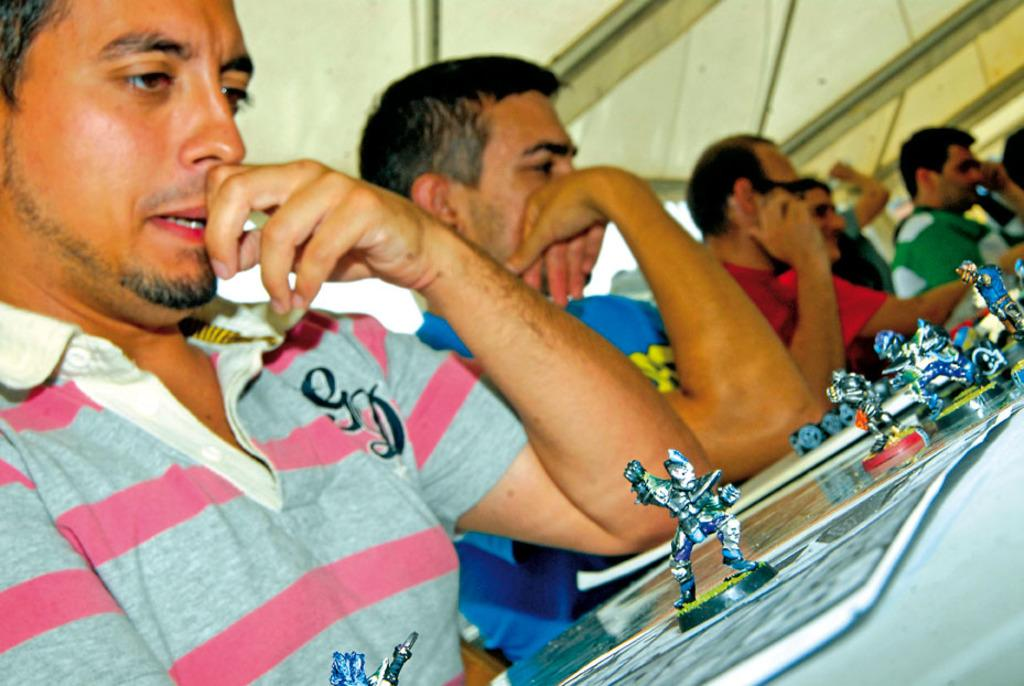Who or what can be seen in the image? There are people in the image. What object is present in the image that people might gather around? There is a table in the image. What is on the table in the image? The table has papers on it, and the papers have toys on them. What structure is visible in the image that provides shelter? There is a roof visible in the image. What type of sea voyage is depicted in the image? There is no sea voyage depicted in the image; it features people, a table, papers, toys, and a roof. What part of the ship can be seen in the image? There is no ship or any part of a ship present in the image. 